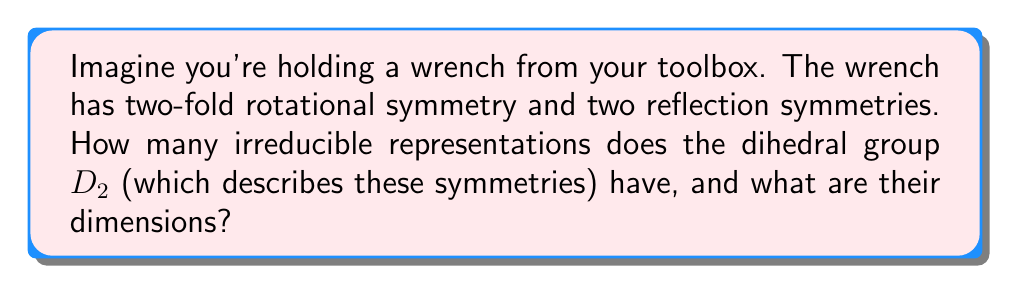Could you help me with this problem? Let's approach this step-by-step:

1) First, recall that the dihedral group $D_2$ has 4 elements:
   - The identity element $e$
   - A 180° rotation $r$
   - Two reflections, let's call them $s$ and $t$

2) For a finite group, the number of irreducible representations is equal to the number of conjugacy classes. Let's find the conjugacy classes of $D_2$:
   - $\{e\}$
   - $\{r\}$
   - $\{s, t\}$

3) We see that there are 3 conjugacy classes, so $D_2$ has 3 irreducible representations.

4) For a group $G$, the sum of squares of dimensions of irreducible representations equals the order of the group:

   $$\sum_{i=1}^k d_i^2 = |G|$$

   Where $k$ is the number of irreducible representations and $d_i$ is the dimension of the $i$-th representation.

5) In this case, we have:

   $$d_1^2 + d_2^2 + d_3^2 = 4$$

6) The only way to satisfy this equation with positive integers is:

   $$1^2 + 1^2 + 1^2 = 4$$

Therefore, $D_2$ has three 1-dimensional irreducible representations.
Answer: 3 irreducible representations, all 1-dimensional 